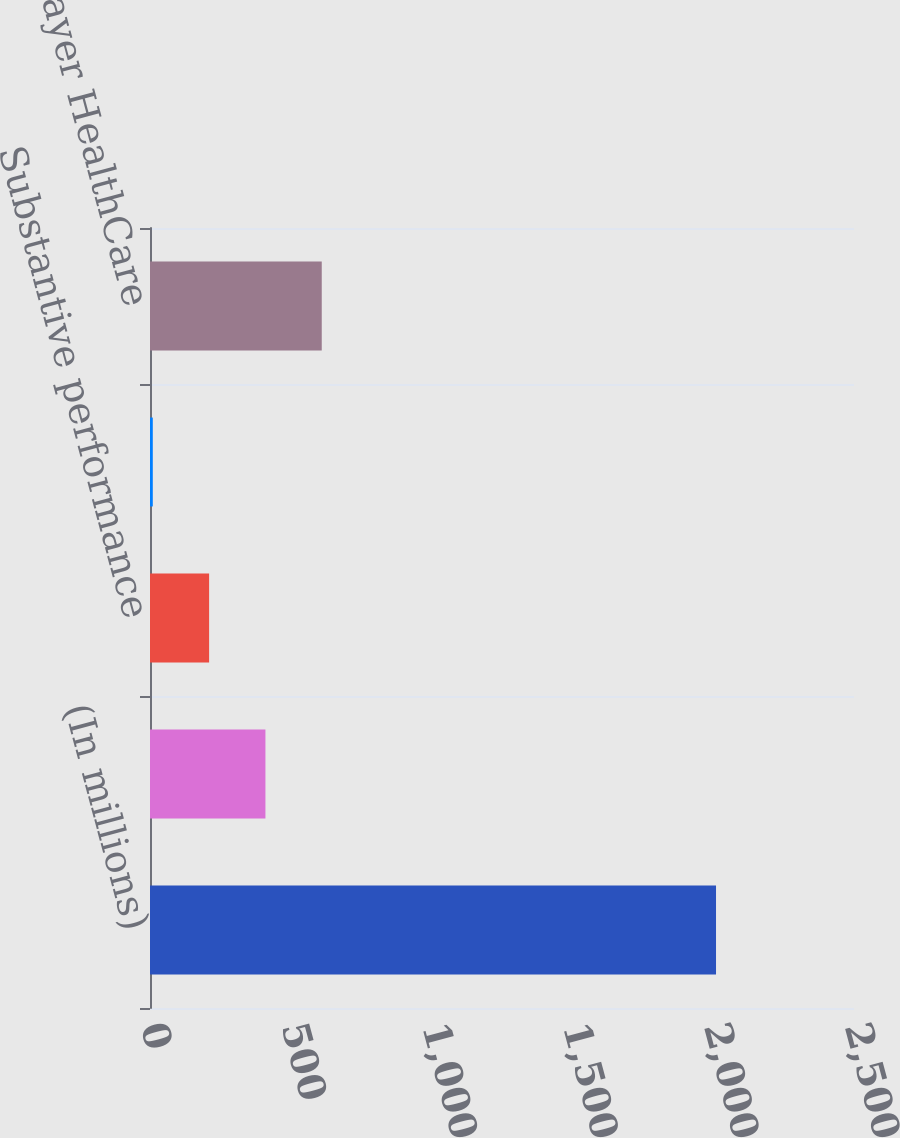<chart> <loc_0><loc_0><loc_500><loc_500><bar_chart><fcel>(In millions)<fcel>Cost-sharing of Regeneron VEGF<fcel>Substantive performance<fcel>Recognition of deferred<fcel>Total Bayer HealthCare<nl><fcel>2010<fcel>409.92<fcel>209.91<fcel>9.9<fcel>609.93<nl></chart> 